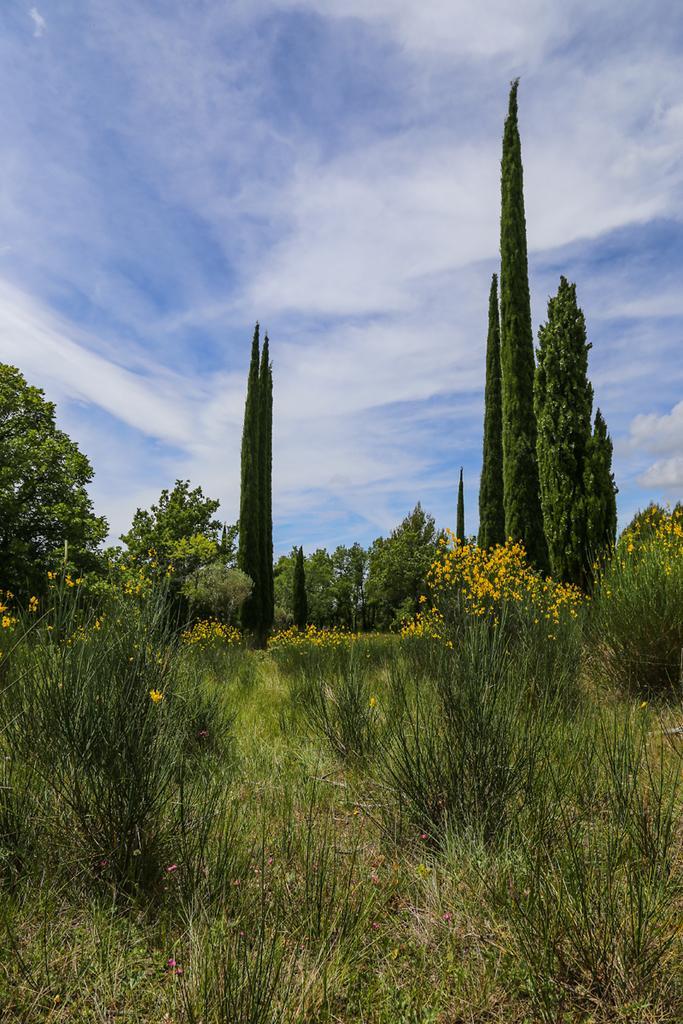Please provide a concise description of this image. In the image there are many plants and trees and some of the plants have beautiful flowers. 